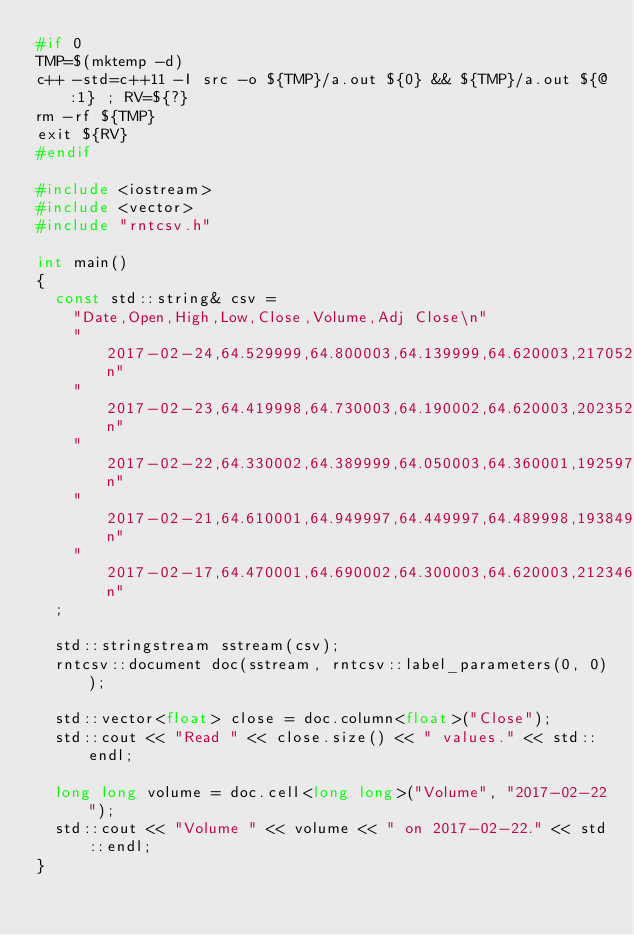<code> <loc_0><loc_0><loc_500><loc_500><_C++_>#if 0
TMP=$(mktemp -d)
c++ -std=c++11 -I src -o ${TMP}/a.out ${0} && ${TMP}/a.out ${@:1} ; RV=${?}
rm -rf ${TMP}
exit ${RV}
#endif

#include <iostream>
#include <vector>
#include "rntcsv.h"

int main()
{
  const std::string& csv =
    "Date,Open,High,Low,Close,Volume,Adj Close\n"
    "2017-02-24,64.529999,64.800003,64.139999,64.620003,21705200,64.620003\n"
    "2017-02-23,64.419998,64.730003,64.190002,64.620003,20235200,64.620003\n"
    "2017-02-22,64.330002,64.389999,64.050003,64.360001,19259700,64.360001\n"
    "2017-02-21,64.610001,64.949997,64.449997,64.489998,19384900,64.489998\n"
    "2017-02-17,64.470001,64.690002,64.300003,64.620003,21234600,64.620003\n"
  ;

  std::stringstream sstream(csv);
  rntcsv::document doc(sstream, rntcsv::label_parameters(0, 0));

  std::vector<float> close = doc.column<float>("Close");
  std::cout << "Read " << close.size() << " values." << std::endl;

  long long volume = doc.cell<long long>("Volume", "2017-02-22");
  std::cout << "Volume " << volume << " on 2017-02-22." << std::endl;
}
</code> 